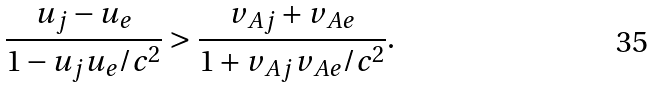Convert formula to latex. <formula><loc_0><loc_0><loc_500><loc_500>\frac { u _ { j } - u _ { e } } { 1 - u _ { j } u _ { e } / c ^ { 2 } } > \frac { v _ { A j } + v _ { A e } } { 1 + v _ { A j } v _ { A e } / c ^ { 2 } } .</formula> 